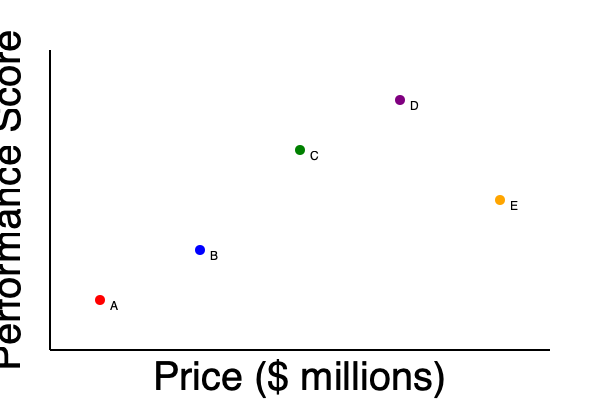Based on the scatter plot showing the price and performance of different military equipment options (A, B, C, D, and E), which option represents the most cost-effective choice for our armed forces? To determine the most cost-effective military equipment, we need to analyze the relationship between price and performance for each option:

1. Interpret the graph:
   - X-axis represents price (in millions of dollars)
   - Y-axis represents performance score (higher is better)

2. Evaluate each option:
   A: Low price, low performance
   B: Moderate price, moderate performance
   C: Moderate-high price, high performance
   D: High price, very high performance
   E: Very high price, moderate-high performance

3. Calculate cost-effectiveness:
   Cost-effectiveness = Performance / Price

   While we don't have exact numbers, we can visually estimate the ratios:
   A: Low ratio (steep slope from origin)
   B: Moderate ratio (moderate slope from origin)
   C: High ratio (steep slope from origin)
   D: Moderate-high ratio (less steep slope than C)
   E: Low ratio (shallow slope from origin)

4. Compare ratios:
   Option C appears to have the steepest slope from the origin, indicating the highest performance-to-price ratio.

5. Consider budget constraints:
   As a conservative approach to government spending, we should also consider that C is not the most expensive option, making it more fiscally responsible than higher-priced alternatives.
Answer: Option C 